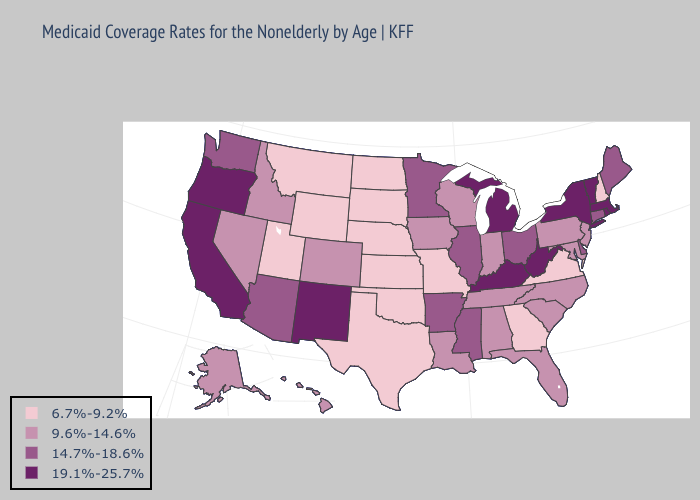Does Oregon have the highest value in the USA?
Short answer required. Yes. What is the highest value in states that border Kansas?
Write a very short answer. 9.6%-14.6%. Does Rhode Island have the highest value in the USA?
Keep it brief. Yes. Does West Virginia have the lowest value in the South?
Keep it brief. No. Name the states that have a value in the range 14.7%-18.6%?
Keep it brief. Arizona, Arkansas, Connecticut, Delaware, Illinois, Maine, Minnesota, Mississippi, Ohio, Washington. What is the value of Tennessee?
Concise answer only. 9.6%-14.6%. What is the value of South Dakota?
Give a very brief answer. 6.7%-9.2%. Does Oregon have the same value as New Hampshire?
Write a very short answer. No. Does the map have missing data?
Give a very brief answer. No. Among the states that border Illinois , does Kentucky have the highest value?
Quick response, please. Yes. Which states have the lowest value in the South?
Write a very short answer. Georgia, Oklahoma, Texas, Virginia. Name the states that have a value in the range 9.6%-14.6%?
Concise answer only. Alabama, Alaska, Colorado, Florida, Hawaii, Idaho, Indiana, Iowa, Louisiana, Maryland, Nevada, New Jersey, North Carolina, Pennsylvania, South Carolina, Tennessee, Wisconsin. Name the states that have a value in the range 19.1%-25.7%?
Keep it brief. California, Kentucky, Massachusetts, Michigan, New Mexico, New York, Oregon, Rhode Island, Vermont, West Virginia. Among the states that border Idaho , does Utah have the lowest value?
Short answer required. Yes. Among the states that border Maryland , does West Virginia have the highest value?
Keep it brief. Yes. 